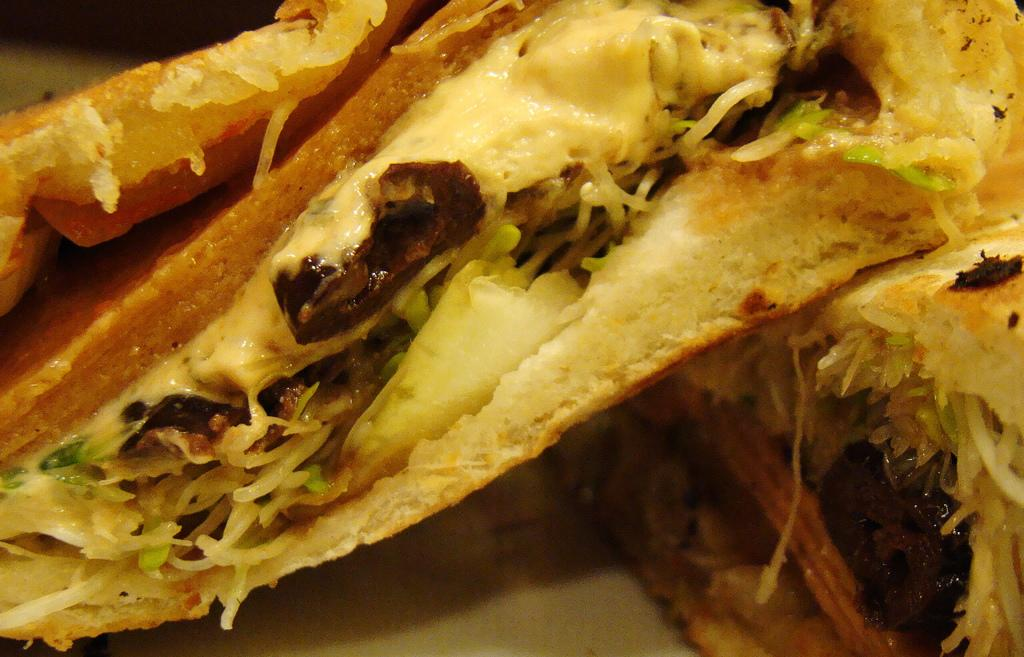What types of items can be seen in the image? There are food items in the image. What type of toothpaste is being used to prepare the food in the image? There is no toothpaste present in the image, as it only contains food items. 